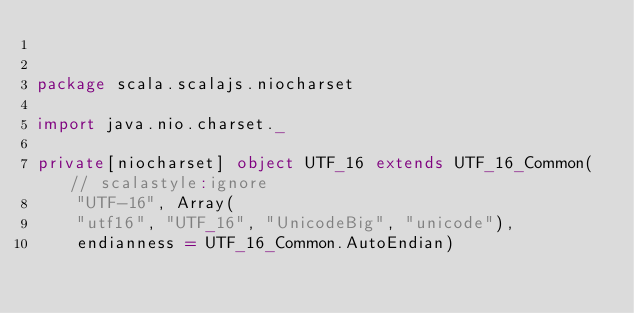<code> <loc_0><loc_0><loc_500><loc_500><_Scala_>

package scala.scalajs.niocharset

import java.nio.charset._

private[niocharset] object UTF_16 extends UTF_16_Common( // scalastyle:ignore
    "UTF-16", Array(
    "utf16", "UTF_16", "UnicodeBig", "unicode"),
    endianness = UTF_16_Common.AutoEndian)
</code> 